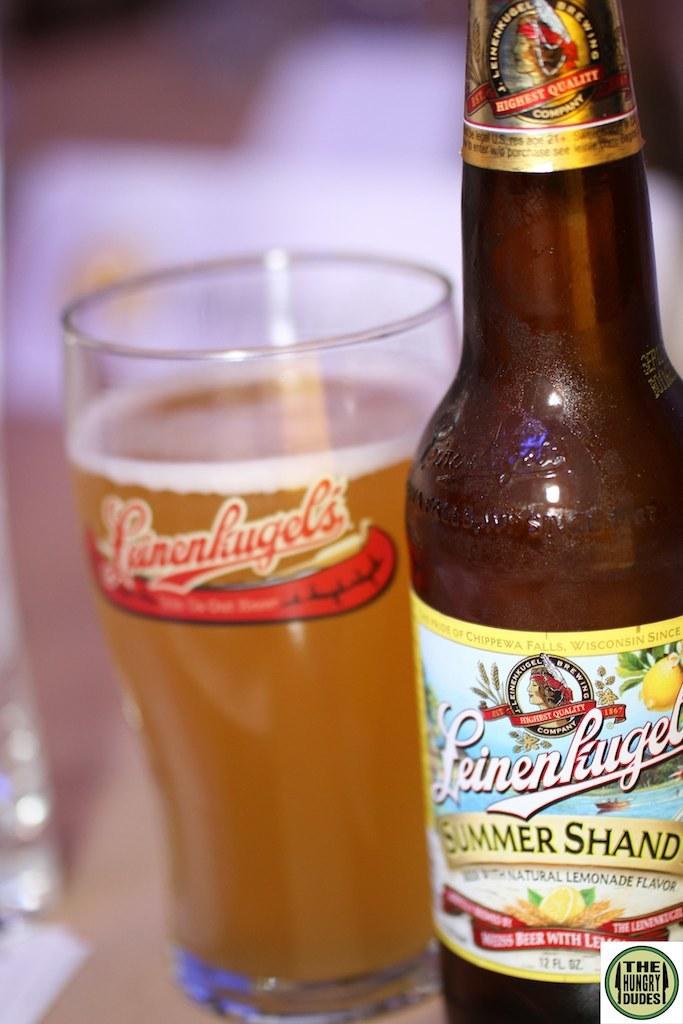What is the brand of beverage?
Your response must be concise. Leinenkugel. 